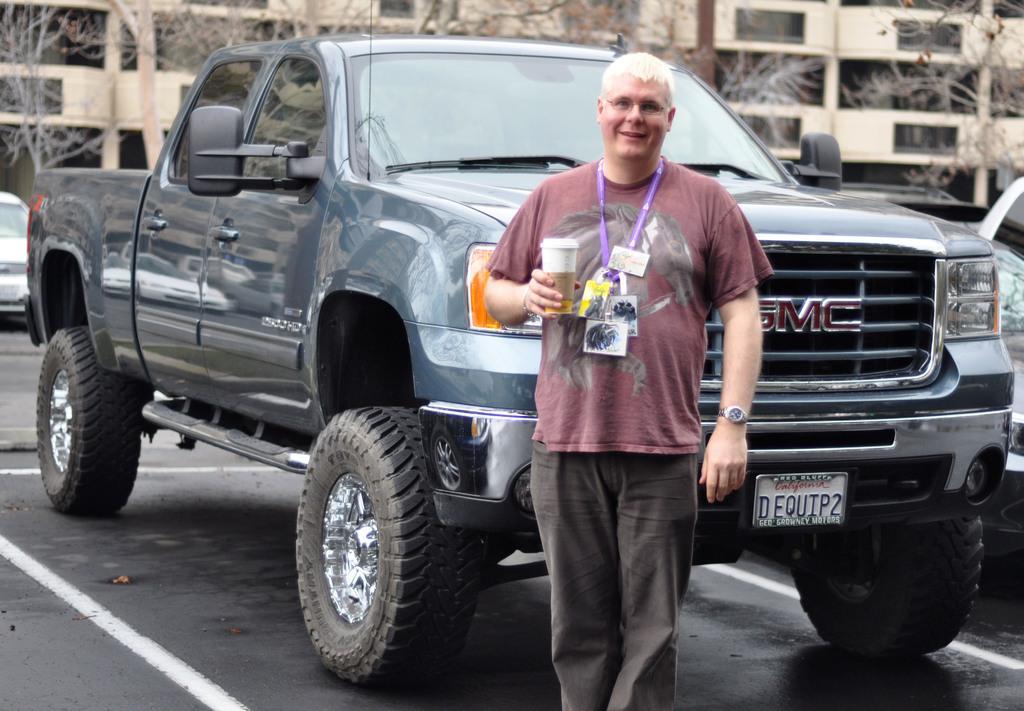Could you give a brief overview of what you see in this image? In this image we can see a man holding a paper cup and standing on the road. Behind the man there is a vehicle. In the background we can see many trees and also buildings. 